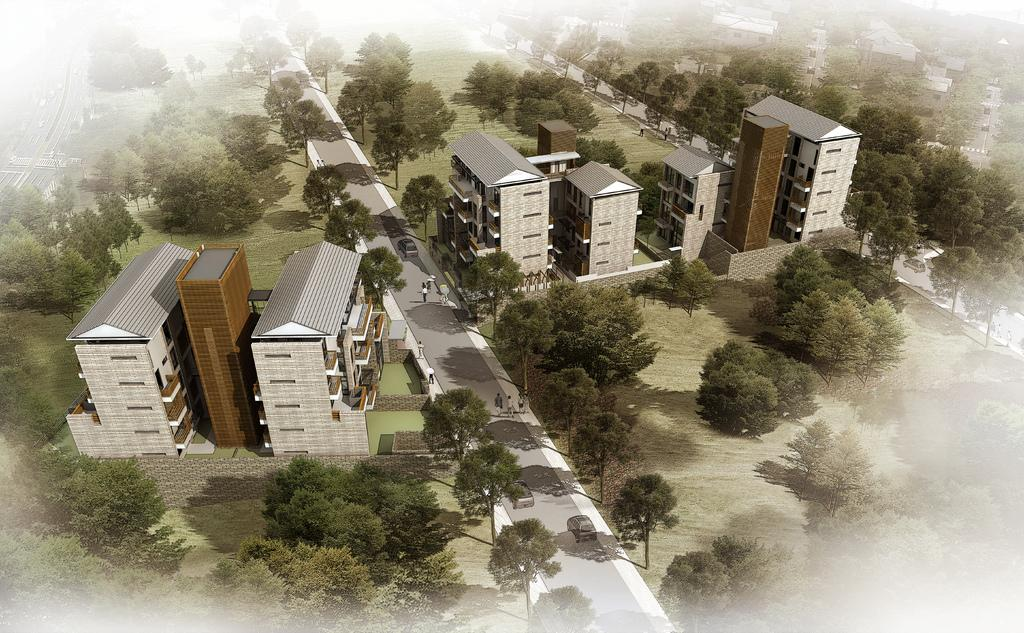What type of view is shown in the image? The image is an aerial view. What structures can be seen in the image? There are buildings in the image. What natural elements are present in the image? There are trees in the image. What man-made features are visible in the image? There are roads in the image. What vehicles can be seen in the image? Cars are visible in the image. What activity are people engaged in within the image? People are walking on the roads in the image. What type of quilt is being used to cover the boy in the image? There is no boy or quilt present in the image. What effect does the image have on the viewer? The image itself does not have an effect on the viewer; the viewer's reaction to the image may vary. 